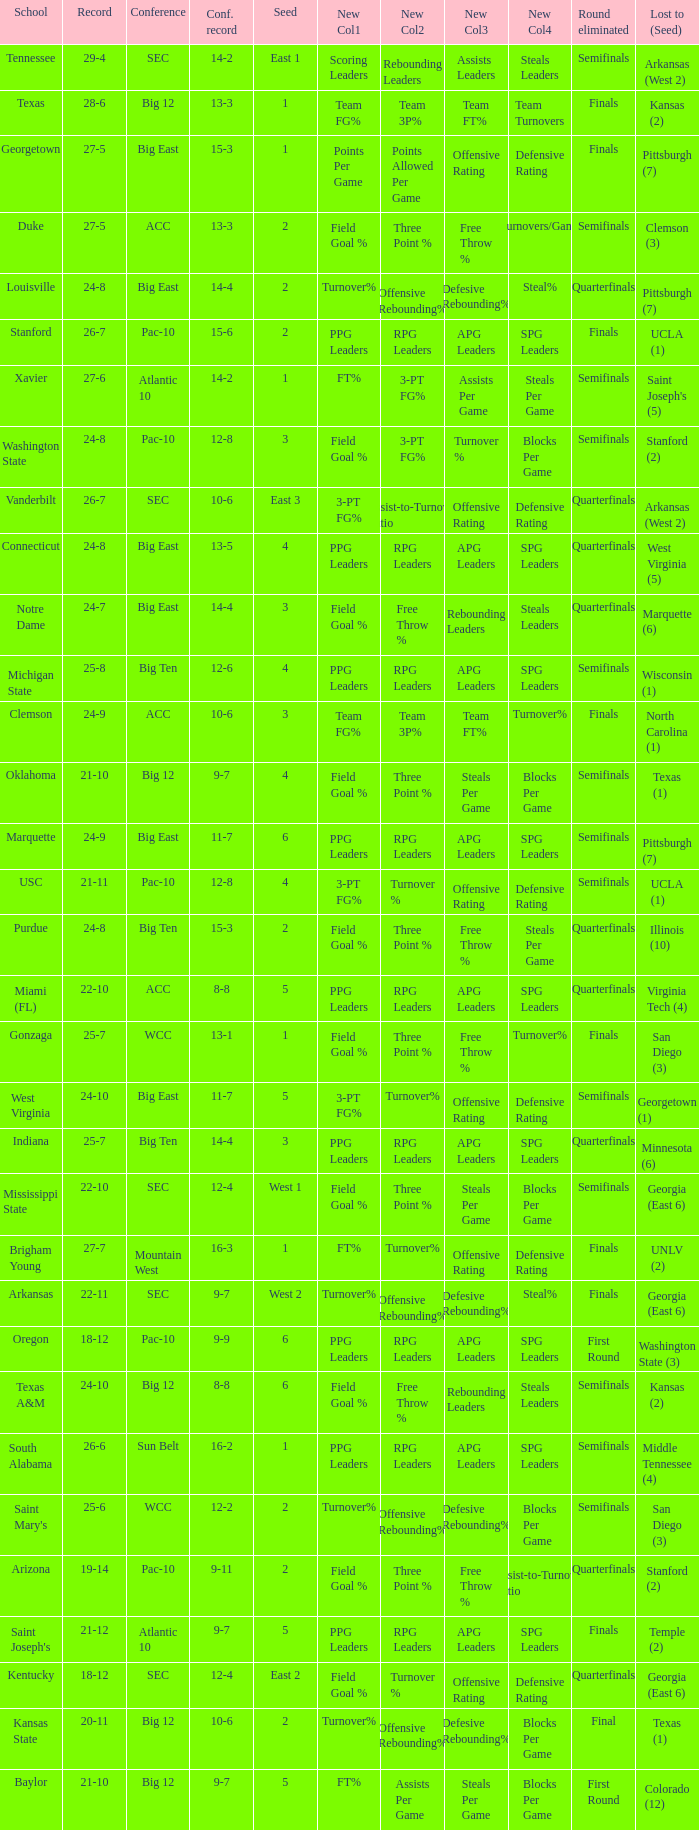Name the round eliminated where conference record is 12-6 Semifinals. 